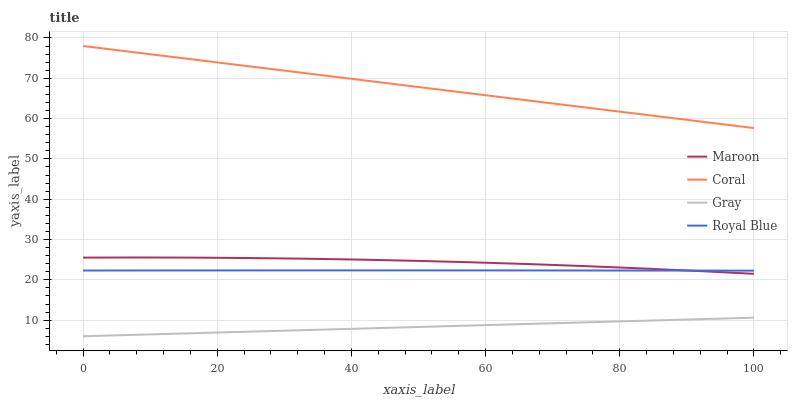Does Gray have the minimum area under the curve?
Answer yes or no. Yes. Does Coral have the maximum area under the curve?
Answer yes or no. Yes. Does Maroon have the minimum area under the curve?
Answer yes or no. No. Does Maroon have the maximum area under the curve?
Answer yes or no. No. Is Gray the smoothest?
Answer yes or no. Yes. Is Maroon the roughest?
Answer yes or no. Yes. Is Coral the smoothest?
Answer yes or no. No. Is Coral the roughest?
Answer yes or no. No. Does Gray have the lowest value?
Answer yes or no. Yes. Does Maroon have the lowest value?
Answer yes or no. No. Does Coral have the highest value?
Answer yes or no. Yes. Does Maroon have the highest value?
Answer yes or no. No. Is Maroon less than Coral?
Answer yes or no. Yes. Is Coral greater than Royal Blue?
Answer yes or no. Yes. Does Royal Blue intersect Maroon?
Answer yes or no. Yes. Is Royal Blue less than Maroon?
Answer yes or no. No. Is Royal Blue greater than Maroon?
Answer yes or no. No. Does Maroon intersect Coral?
Answer yes or no. No. 